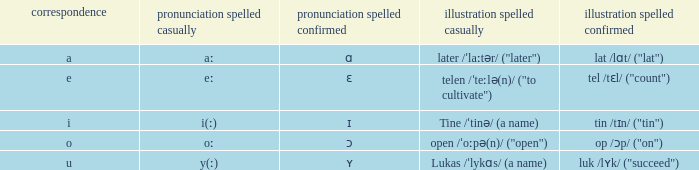What is Example Spelled Free, when Example Spelled Checked is "op /ɔp/ ("on")"? Open /ˈoːpə(n)/ ("open"). 